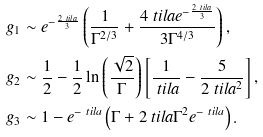<formula> <loc_0><loc_0><loc_500><loc_500>g _ { 1 } & \sim e ^ { - \frac { 2 \ t i l a } { 3 } } \left ( \frac { 1 } { \Gamma ^ { 2 / 3 } } + \frac { 4 \ t i l a e ^ { - \frac { 2 \ t i l a } { 3 } } } { 3 \Gamma ^ { 4 / 3 } } \right ) , \\ g _ { 2 } & \sim \frac { 1 } { 2 } - \frac { 1 } { 2 } \ln \left ( \frac { \sqrt { 2 } } { \Gamma } \right ) \left [ \frac { 1 } { \ t i l a } - \frac { 5 } { 2 \ t i l a ^ { 2 } } \right ] , \\ g _ { 3 } & \sim 1 - e ^ { - \ t i l a } \left ( \Gamma + 2 \ t i l a \Gamma ^ { 2 } e ^ { - \ t i l a } \right ) .</formula> 